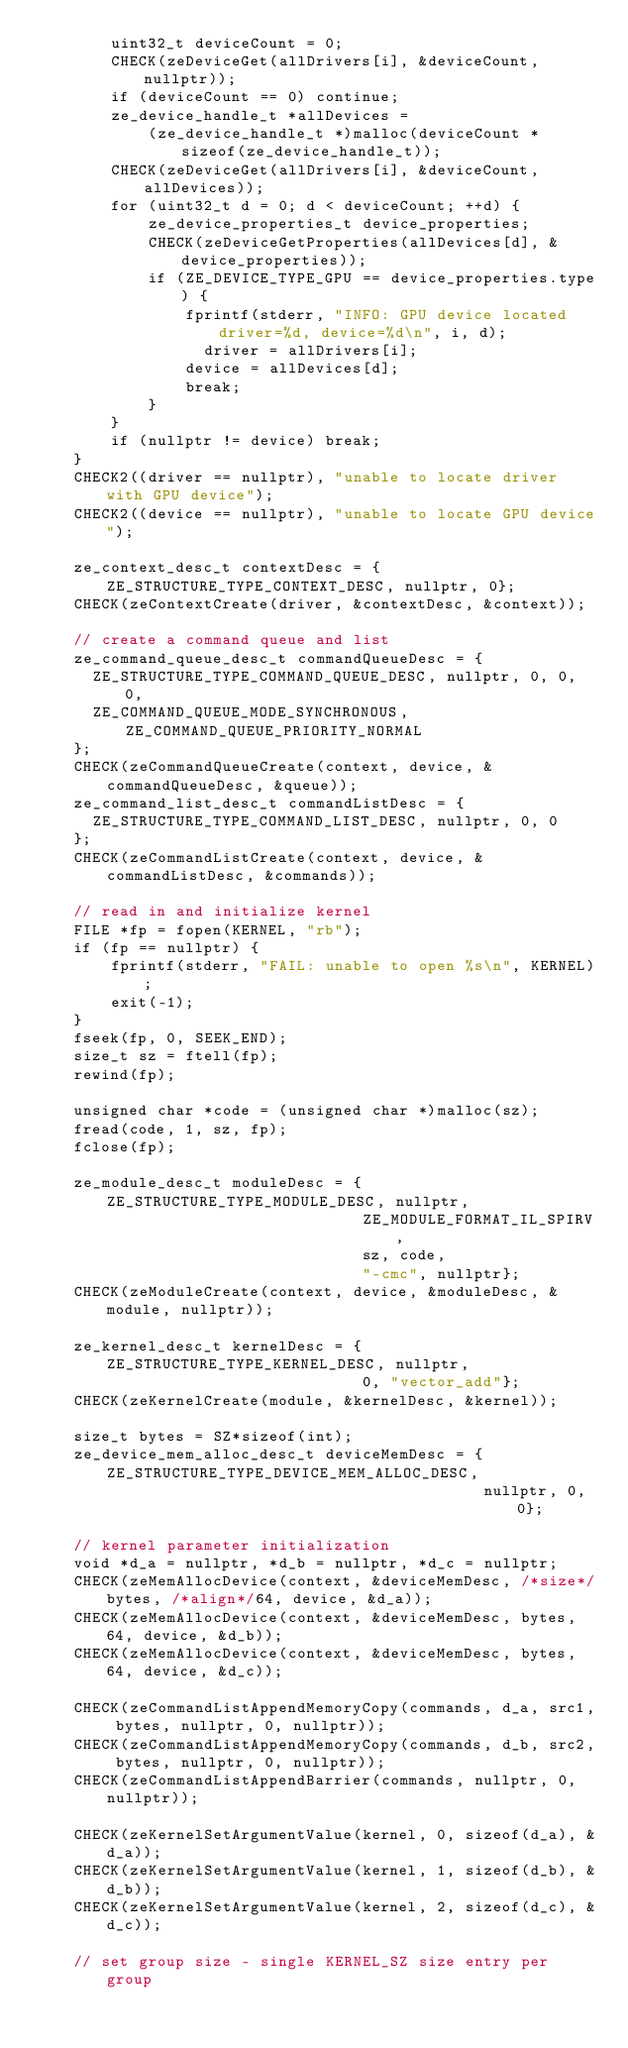Convert code to text. <code><loc_0><loc_0><loc_500><loc_500><_C++_>        uint32_t deviceCount = 0;
        CHECK(zeDeviceGet(allDrivers[i], &deviceCount, nullptr));
        if (deviceCount == 0) continue;
        ze_device_handle_t *allDevices =
            (ze_device_handle_t *)malloc(deviceCount * sizeof(ze_device_handle_t));
        CHECK(zeDeviceGet(allDrivers[i], &deviceCount, allDevices));
        for (uint32_t d = 0; d < deviceCount; ++d) {
            ze_device_properties_t device_properties;
            CHECK(zeDeviceGetProperties(allDevices[d], &device_properties));
            if (ZE_DEVICE_TYPE_GPU == device_properties.type) {
                fprintf(stderr, "INFO: GPU device located driver=%d, device=%d\n", i, d);
	              driver = allDrivers[i];
                device = allDevices[d];
                break;
            }
        }
        if (nullptr != device) break;
    }
    CHECK2((driver == nullptr), "unable to locate driver with GPU device");
    CHECK2((device == nullptr), "unable to locate GPU device");

    ze_context_desc_t contextDesc = {ZE_STRUCTURE_TYPE_CONTEXT_DESC, nullptr, 0};
    CHECK(zeContextCreate(driver, &contextDesc, &context));

    // create a command queue and list
    ze_command_queue_desc_t commandQueueDesc = {
      ZE_STRUCTURE_TYPE_COMMAND_QUEUE_DESC, nullptr, 0, 0, 0,
      ZE_COMMAND_QUEUE_MODE_SYNCHRONOUS, ZE_COMMAND_QUEUE_PRIORITY_NORMAL
    };
    CHECK(zeCommandQueueCreate(context, device, &commandQueueDesc, &queue));
    ze_command_list_desc_t commandListDesc = { 
      ZE_STRUCTURE_TYPE_COMMAND_LIST_DESC, nullptr, 0, 0
    };
    CHECK(zeCommandListCreate(context, device, &commandListDesc, &commands));

    // read in and initialize kernel
    FILE *fp = fopen(KERNEL, "rb");
    if (fp == nullptr) {
        fprintf(stderr, "FAIL: unable to open %s\n", KERNEL);
        exit(-1);
    }
    fseek(fp, 0, SEEK_END);
    size_t sz = ftell(fp);
    rewind(fp);

    unsigned char *code = (unsigned char *)malloc(sz);
    fread(code, 1, sz, fp);
    fclose(fp);

    ze_module_desc_t moduleDesc = {ZE_STRUCTURE_TYPE_MODULE_DESC, nullptr,
                                   ZE_MODULE_FORMAT_IL_SPIRV,
                                   sz, code,
                                   "-cmc", nullptr};
    CHECK(zeModuleCreate(context, device, &moduleDesc, &module, nullptr));

    ze_kernel_desc_t kernelDesc = {ZE_STRUCTURE_TYPE_KERNEL_DESC, nullptr,
                                   0, "vector_add"};
    CHECK(zeKernelCreate(module, &kernelDesc, &kernel));

    size_t bytes = SZ*sizeof(int);
    ze_device_mem_alloc_desc_t deviceMemDesc = {ZE_STRUCTURE_TYPE_DEVICE_MEM_ALLOC_DESC,
                                                nullptr, 0, 0};

    // kernel parameter initialization
    void *d_a = nullptr, *d_b = nullptr, *d_c = nullptr;
    CHECK(zeMemAllocDevice(context, &deviceMemDesc, /*size*/bytes, /*align*/64, device, &d_a));
    CHECK(zeMemAllocDevice(context, &deviceMemDesc, bytes, 64, device, &d_b));
    CHECK(zeMemAllocDevice(context, &deviceMemDesc, bytes, 64, device, &d_c));

    CHECK(zeCommandListAppendMemoryCopy(commands, d_a, src1, bytes, nullptr, 0, nullptr));
    CHECK(zeCommandListAppendMemoryCopy(commands, d_b, src2, bytes, nullptr, 0, nullptr));
    CHECK(zeCommandListAppendBarrier(commands, nullptr, 0, nullptr));

    CHECK(zeKernelSetArgumentValue(kernel, 0, sizeof(d_a), &d_a));
    CHECK(zeKernelSetArgumentValue(kernel, 1, sizeof(d_b), &d_b));
    CHECK(zeKernelSetArgumentValue(kernel, 2, sizeof(d_c), &d_c));

    // set group size - single KERNEL_SZ size entry per group</code> 